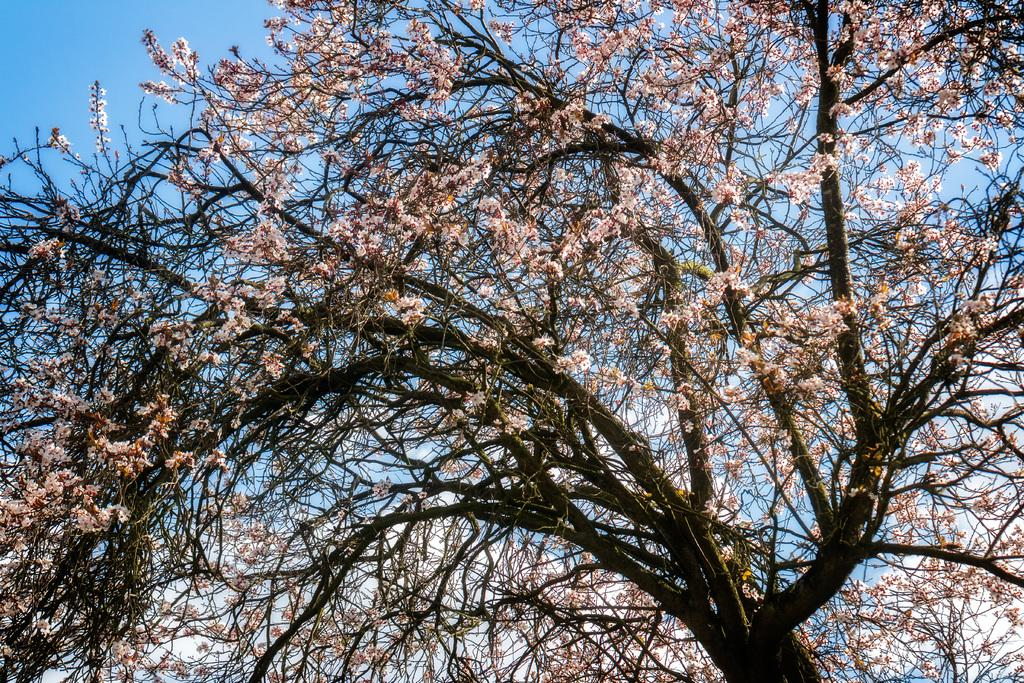What type of tree is present in the image? There is a tree with flowers in the image. Where is the tree located in the image? The tree is in the middle of the image. What can be seen in the background of the image? The sky is visible in the background of the image. What type of pump is used to irrigate the flowers on the tree in the image? There is no pump present in the image, and the flowers on the tree do not require irrigation. 